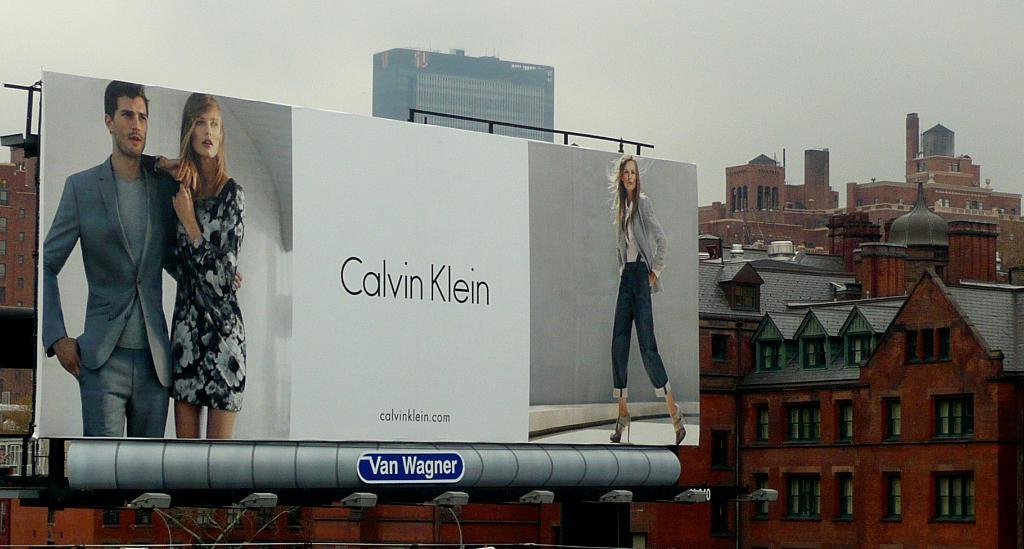<image>
Present a compact description of the photo's key features. A large billboard ad for Calvin Klein in a city. 